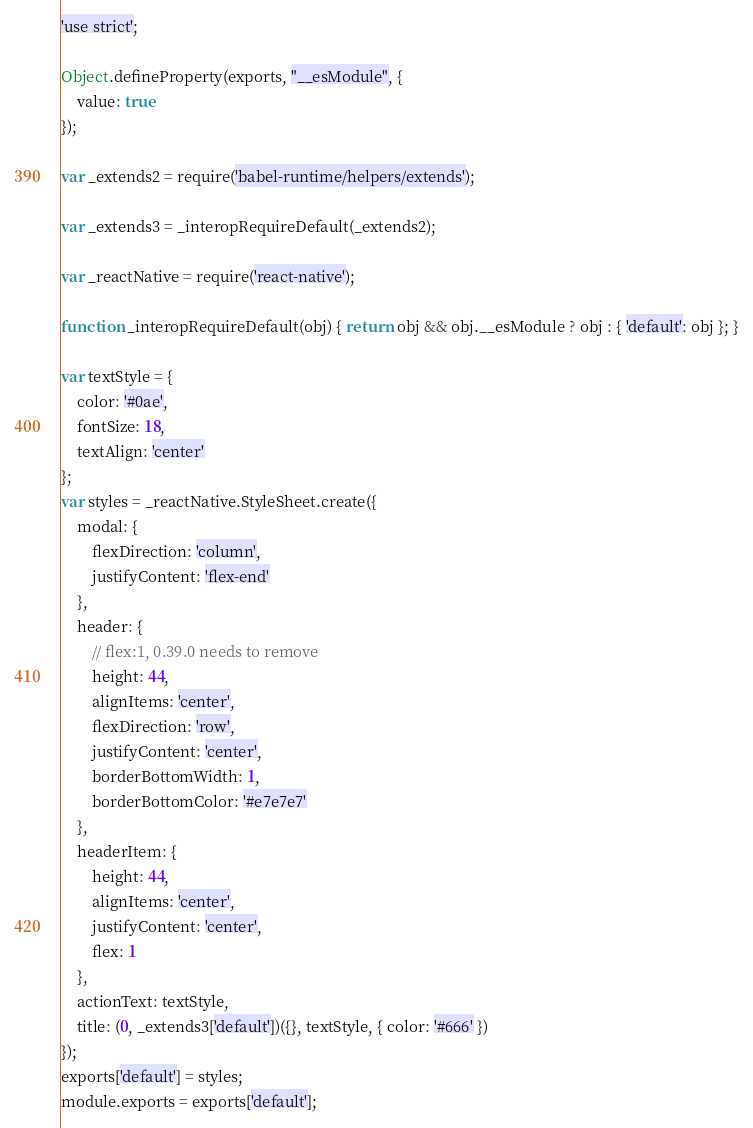Convert code to text. <code><loc_0><loc_0><loc_500><loc_500><_JavaScript_>'use strict';

Object.defineProperty(exports, "__esModule", {
    value: true
});

var _extends2 = require('babel-runtime/helpers/extends');

var _extends3 = _interopRequireDefault(_extends2);

var _reactNative = require('react-native');

function _interopRequireDefault(obj) { return obj && obj.__esModule ? obj : { 'default': obj }; }

var textStyle = {
    color: '#0ae',
    fontSize: 18,
    textAlign: 'center'
};
var styles = _reactNative.StyleSheet.create({
    modal: {
        flexDirection: 'column',
        justifyContent: 'flex-end'
    },
    header: {
        // flex:1, 0.39.0 needs to remove
        height: 44,
        alignItems: 'center',
        flexDirection: 'row',
        justifyContent: 'center',
        borderBottomWidth: 1,
        borderBottomColor: '#e7e7e7'
    },
    headerItem: {
        height: 44,
        alignItems: 'center',
        justifyContent: 'center',
        flex: 1
    },
    actionText: textStyle,
    title: (0, _extends3['default'])({}, textStyle, { color: '#666' })
});
exports['default'] = styles;
module.exports = exports['default'];</code> 